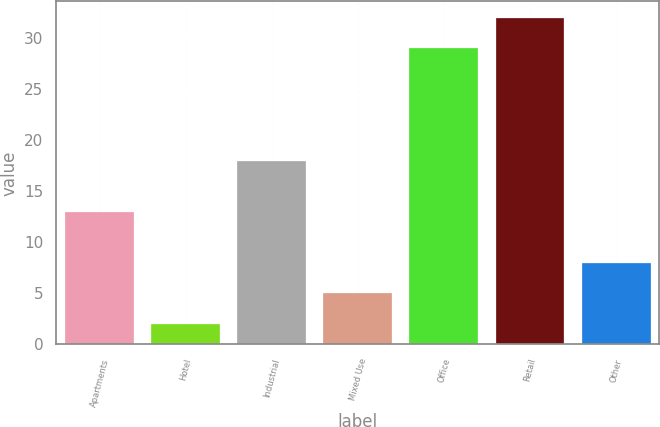Convert chart. <chart><loc_0><loc_0><loc_500><loc_500><bar_chart><fcel>Apartments<fcel>Hotel<fcel>Industrial<fcel>Mixed Use<fcel>Office<fcel>Retail<fcel>Other<nl><fcel>13<fcel>2<fcel>18<fcel>5<fcel>29<fcel>32<fcel>8<nl></chart> 